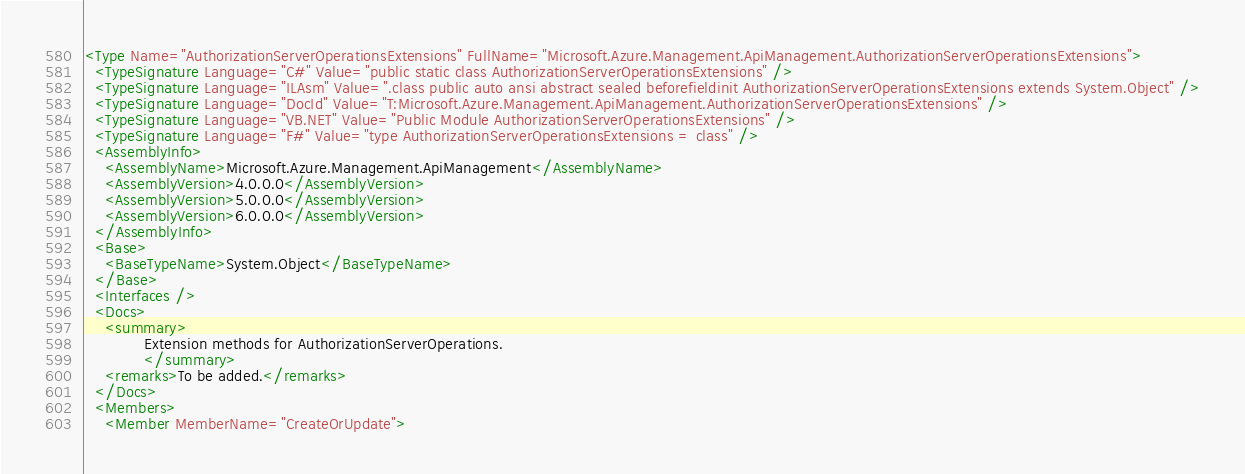Convert code to text. <code><loc_0><loc_0><loc_500><loc_500><_XML_><Type Name="AuthorizationServerOperationsExtensions" FullName="Microsoft.Azure.Management.ApiManagement.AuthorizationServerOperationsExtensions">
  <TypeSignature Language="C#" Value="public static class AuthorizationServerOperationsExtensions" />
  <TypeSignature Language="ILAsm" Value=".class public auto ansi abstract sealed beforefieldinit AuthorizationServerOperationsExtensions extends System.Object" />
  <TypeSignature Language="DocId" Value="T:Microsoft.Azure.Management.ApiManagement.AuthorizationServerOperationsExtensions" />
  <TypeSignature Language="VB.NET" Value="Public Module AuthorizationServerOperationsExtensions" />
  <TypeSignature Language="F#" Value="type AuthorizationServerOperationsExtensions = class" />
  <AssemblyInfo>
    <AssemblyName>Microsoft.Azure.Management.ApiManagement</AssemblyName>
    <AssemblyVersion>4.0.0.0</AssemblyVersion>
    <AssemblyVersion>5.0.0.0</AssemblyVersion>
    <AssemblyVersion>6.0.0.0</AssemblyVersion>
  </AssemblyInfo>
  <Base>
    <BaseTypeName>System.Object</BaseTypeName>
  </Base>
  <Interfaces />
  <Docs>
    <summary>
            Extension methods for AuthorizationServerOperations.
            </summary>
    <remarks>To be added.</remarks>
  </Docs>
  <Members>
    <Member MemberName="CreateOrUpdate"></code> 